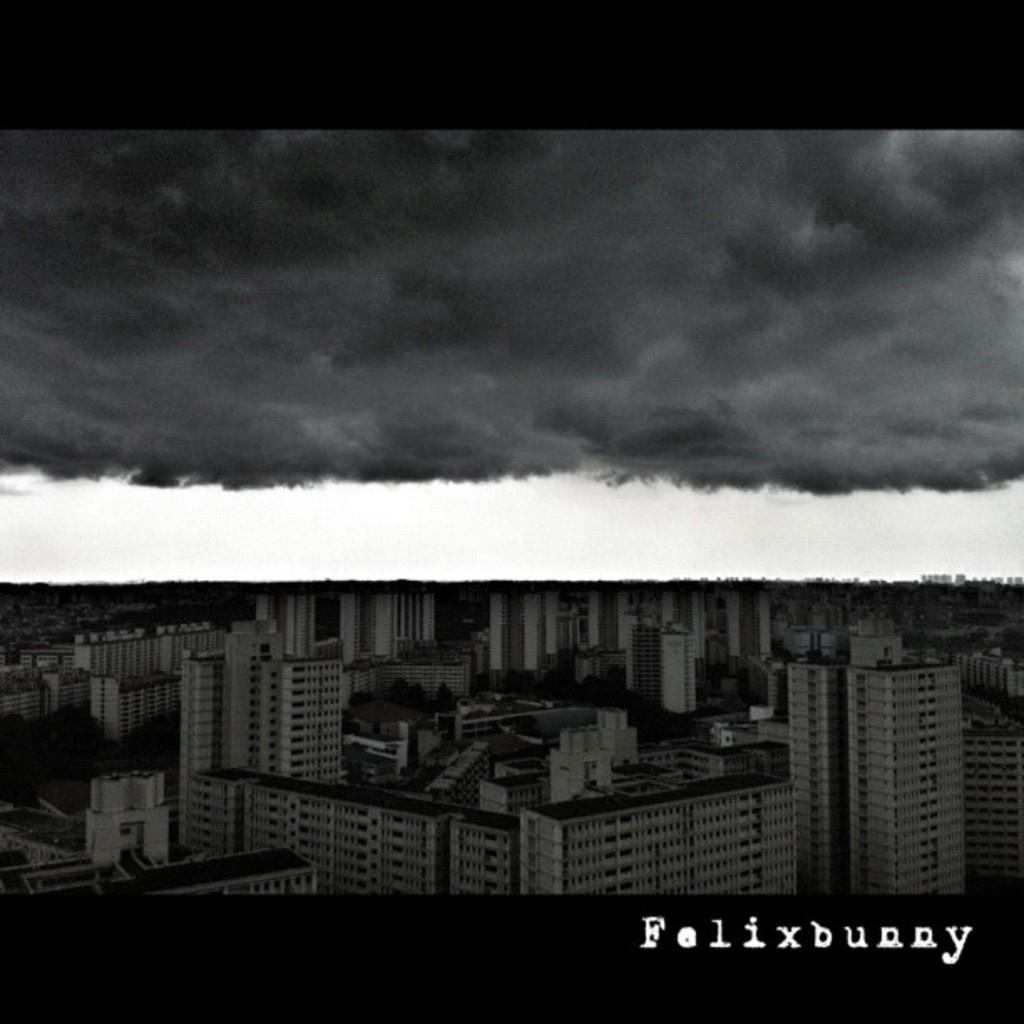What type of artwork is the image? The image is a collage. What subjects are depicted in the collage? There is a picture of buildings and a picture of snow in the collage. What type of crime is being committed in the image? There is no crime depicted in the image; it is a collage featuring pictures of buildings and snow. What type of music can be heard in the image? There is no music present in the image; it is a visual representation of buildings and snow. 